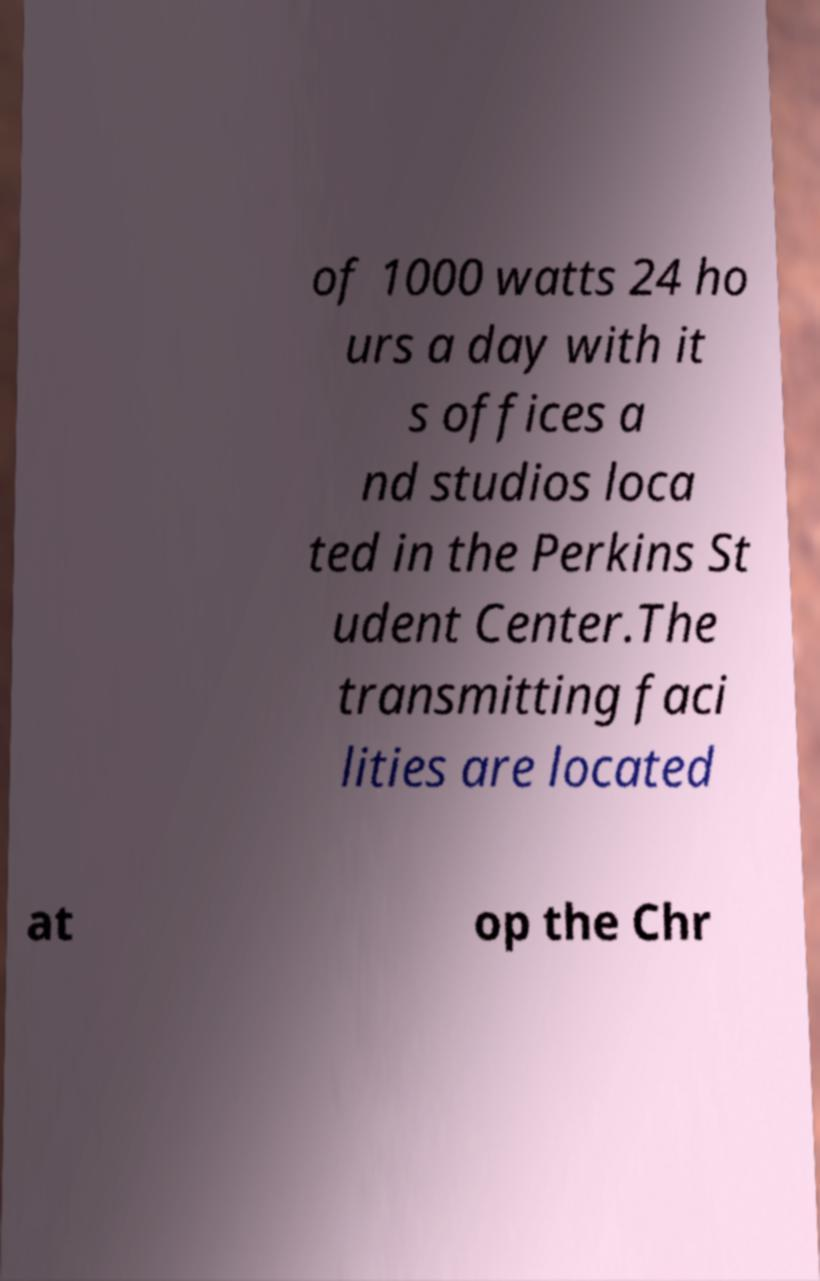There's text embedded in this image that I need extracted. Can you transcribe it verbatim? of 1000 watts 24 ho urs a day with it s offices a nd studios loca ted in the Perkins St udent Center.The transmitting faci lities are located at op the Chr 